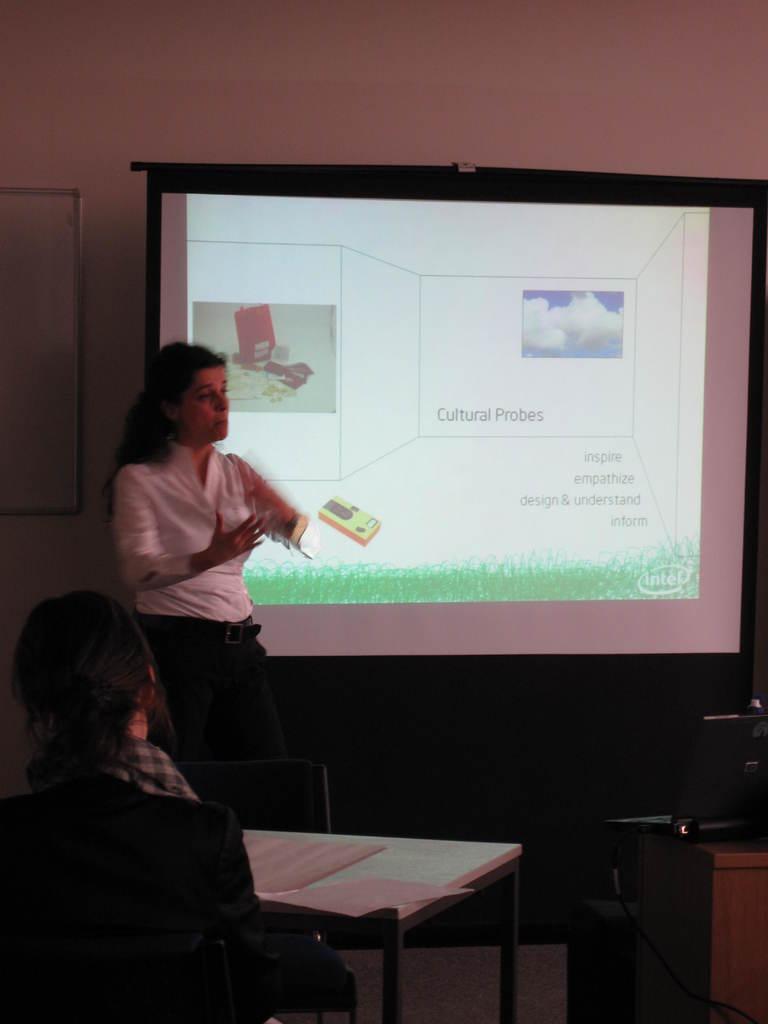How would you summarize this image in a sentence or two? In the foreground of this picture, there is a woman sitting on the chair near a table and few papers are placed on the table and on the right side of the image there is a table and a laptop on it. In the background, there is a woman in black and white dress standing near a screen and explaining something. Behind screen, there is a board and the wall. 